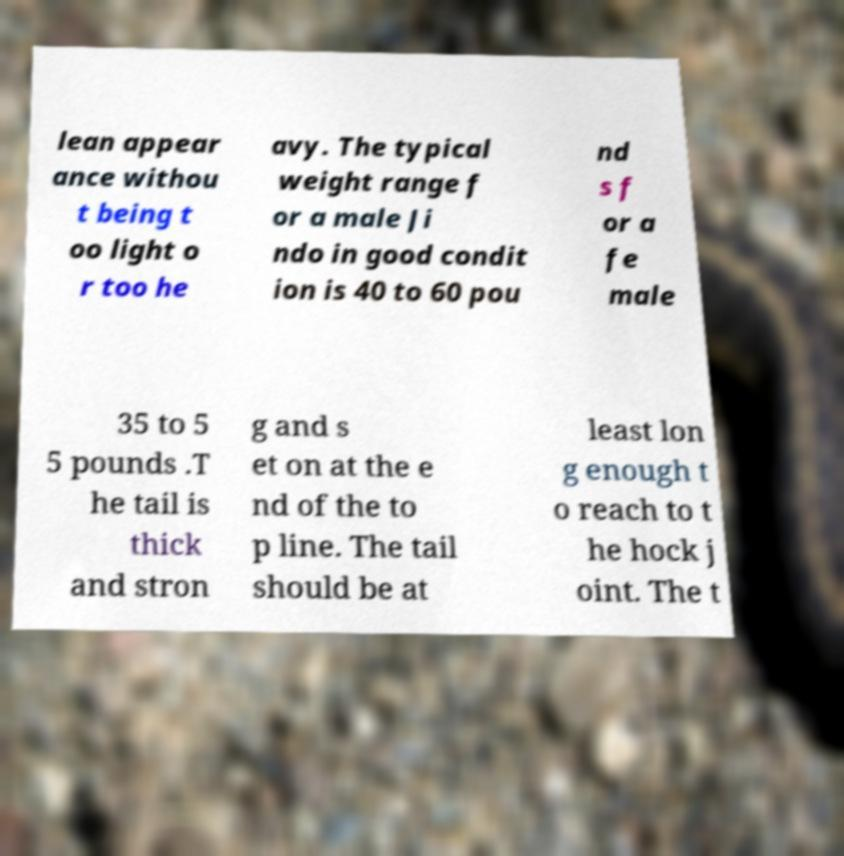For documentation purposes, I need the text within this image transcribed. Could you provide that? lean appear ance withou t being t oo light o r too he avy. The typical weight range f or a male Ji ndo in good condit ion is 40 to 60 pou nd s f or a fe male 35 to 5 5 pounds .T he tail is thick and stron g and s et on at the e nd of the to p line. The tail should be at least lon g enough t o reach to t he hock j oint. The t 